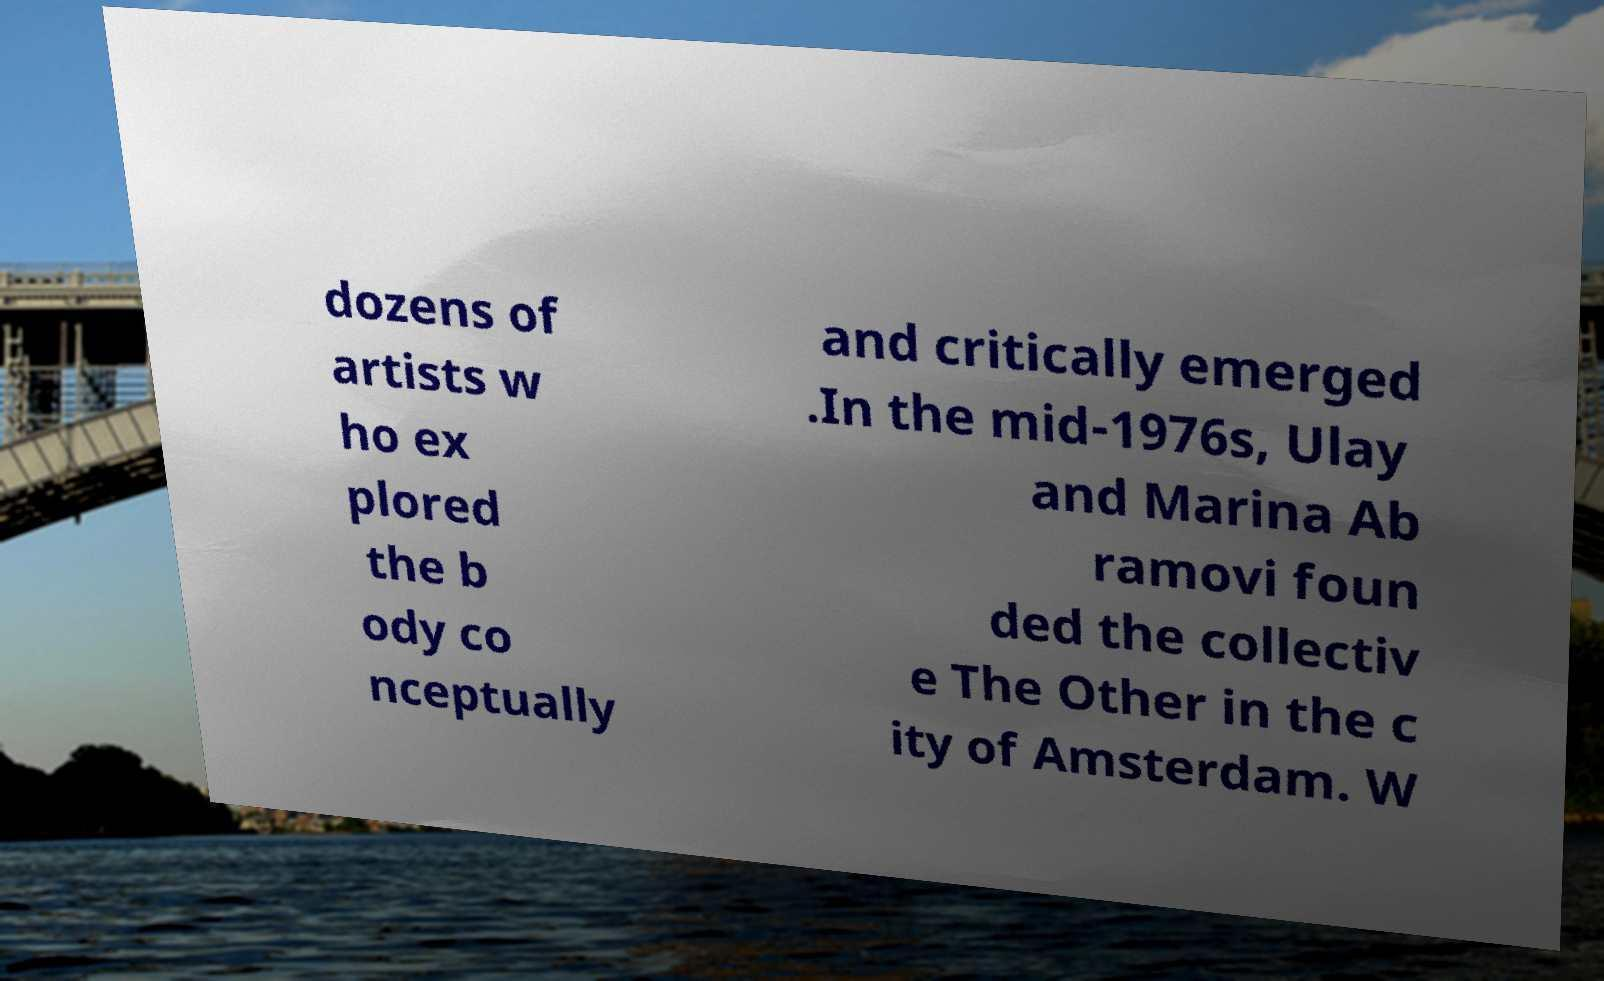Could you assist in decoding the text presented in this image and type it out clearly? dozens of artists w ho ex plored the b ody co nceptually and critically emerged .In the mid-1976s, Ulay and Marina Ab ramovi foun ded the collectiv e The Other in the c ity of Amsterdam. W 